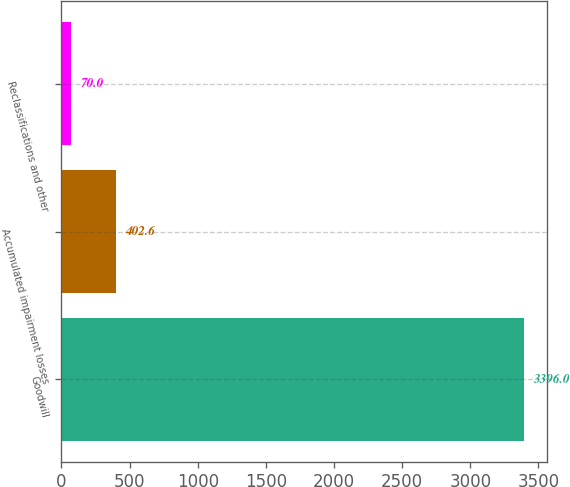Convert chart to OTSL. <chart><loc_0><loc_0><loc_500><loc_500><bar_chart><fcel>Goodwill<fcel>Accumulated impairment losses<fcel>Reclassifications and other<nl><fcel>3396<fcel>402.6<fcel>70<nl></chart> 